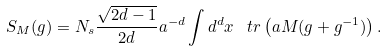Convert formula to latex. <formula><loc_0><loc_0><loc_500><loc_500>S _ { M } ( g ) = N _ { s } \frac { \sqrt { 2 d - 1 } } { 2 d } a ^ { - d } \int d ^ { d } x \, \ t r \left ( a M ( g + g ^ { - 1 } ) \right ) .</formula> 